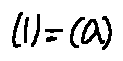<formula> <loc_0><loc_0><loc_500><loc_500>( l ) = ( \lambda )</formula> 